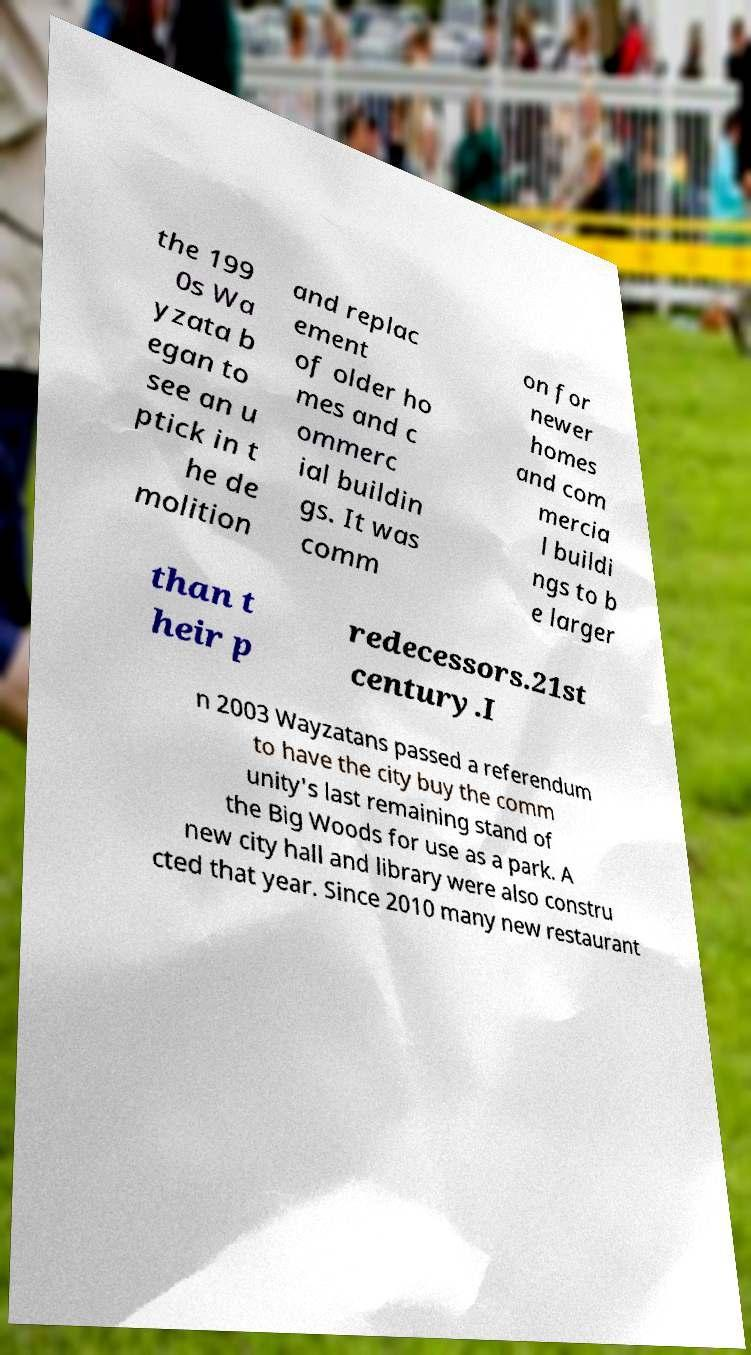Can you read and provide the text displayed in the image?This photo seems to have some interesting text. Can you extract and type it out for me? the 199 0s Wa yzata b egan to see an u ptick in t he de molition and replac ement of older ho mes and c ommerc ial buildin gs. It was comm on for newer homes and com mercia l buildi ngs to b e larger than t heir p redecessors.21st century.I n 2003 Wayzatans passed a referendum to have the city buy the comm unity's last remaining stand of the Big Woods for use as a park. A new city hall and library were also constru cted that year. Since 2010 many new restaurant 